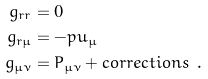Convert formula to latex. <formula><loc_0><loc_0><loc_500><loc_500>g _ { r r } & = 0 \\ g _ { r \mu } & = - p u _ { \mu } \\ g _ { \mu \nu } & = P _ { \mu \nu } + c o r r e c t i o n s \ .</formula> 